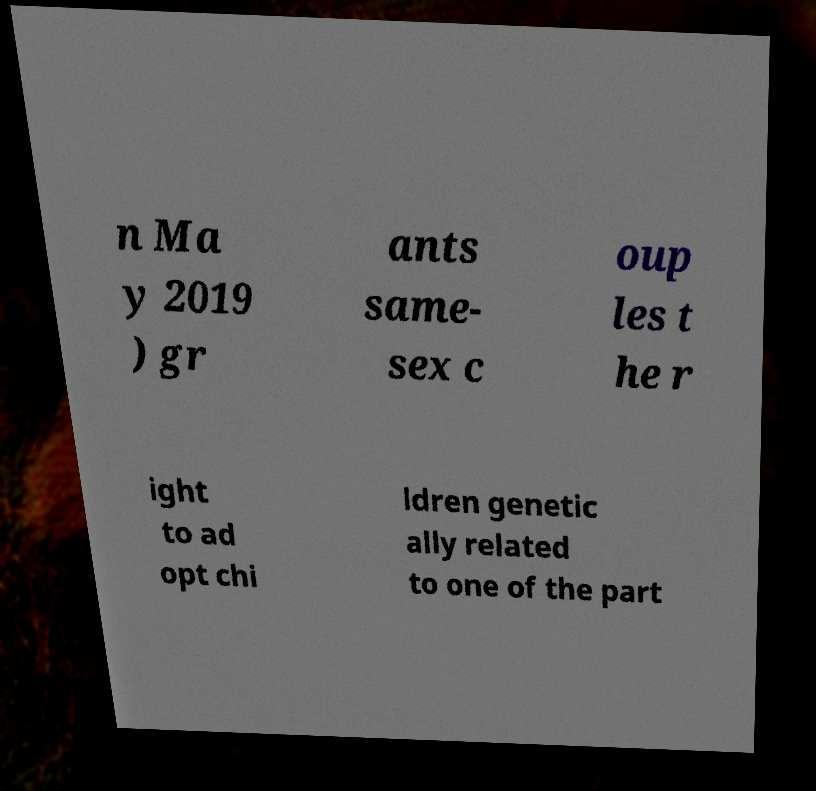I need the written content from this picture converted into text. Can you do that? n Ma y 2019 ) gr ants same- sex c oup les t he r ight to ad opt chi ldren genetic ally related to one of the part 